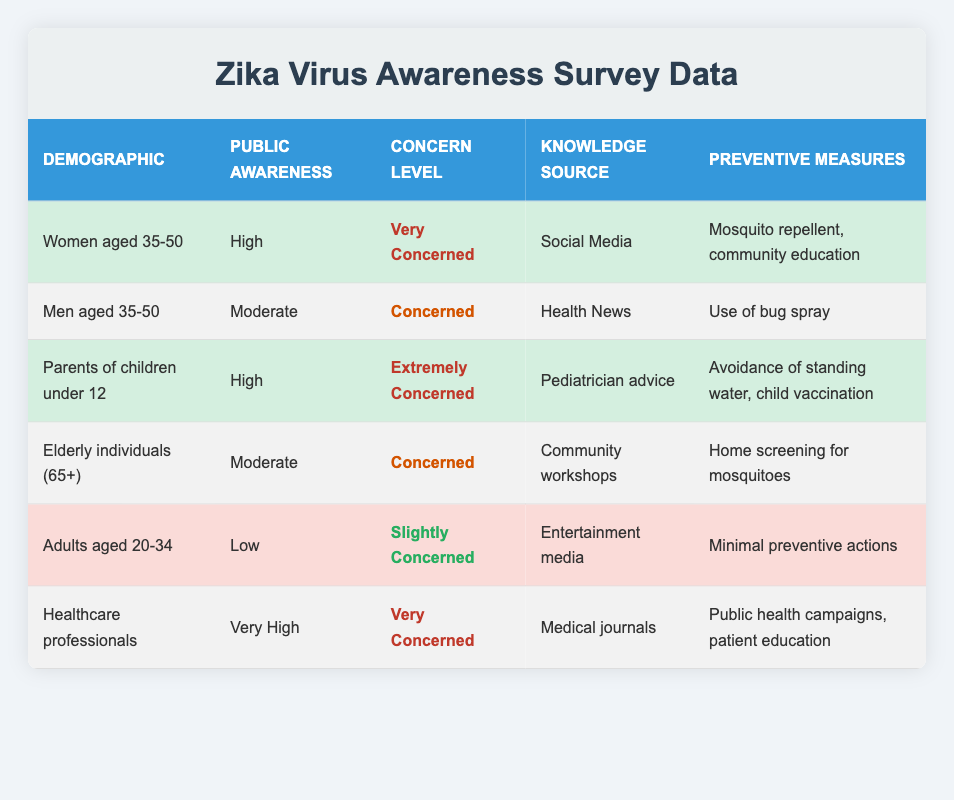What is the public awareness level of parents of children under 12? Referring to the table, the row corresponding to "Parents of children under 12" shows that their public awareness level is listed as "High."
Answer: High Which demographic shows the highest level of concern regarding Zika virus transmission? In the table, the "Parents of children under 12" demographic is noted as "Extremely Concerned," which is higher than others like "Women aged 35-50" who are "Very Concerned."
Answer: Parents of children under 12 Is the preventive measure of using mosquito repellent taken by men aged 35-50? The table indicates that men aged 35-50 have taken the preventive measure of "Use of bug spray," which is a similar preventive action to using mosquito repellent. Therefore, the statement is true.
Answer: Yes How many demographics are concerned about Zika virus transmission at a level of "Concerned" or higher? There are three demographics that categorize under "Concerned" or higher: "Women aged 35-50" (Very Concerned), "Parents of children under 12" (Extremely Concerned), "Men aged 35-50" (Concerned), and "Elderly individuals (65+)" (Concerned). This totals four demographics.
Answer: Four What is the average public awareness level across all groups? To assess the average public awareness level, we can assign numerical values: Very High (4), High (3), Moderate (2), and Low (1). The counts are: Healthcare professionals (4), Women aged 35-50 (3), Parents of children under 12 (3), Elderly individuals (2), Men aged 35-50 (2), and Adults aged 20-34 (1). Summing these values gives us 15, and with 6 groups, the average is 15/6 = 2.5, which corresponds to 'Moderate.'
Answer: Moderate 